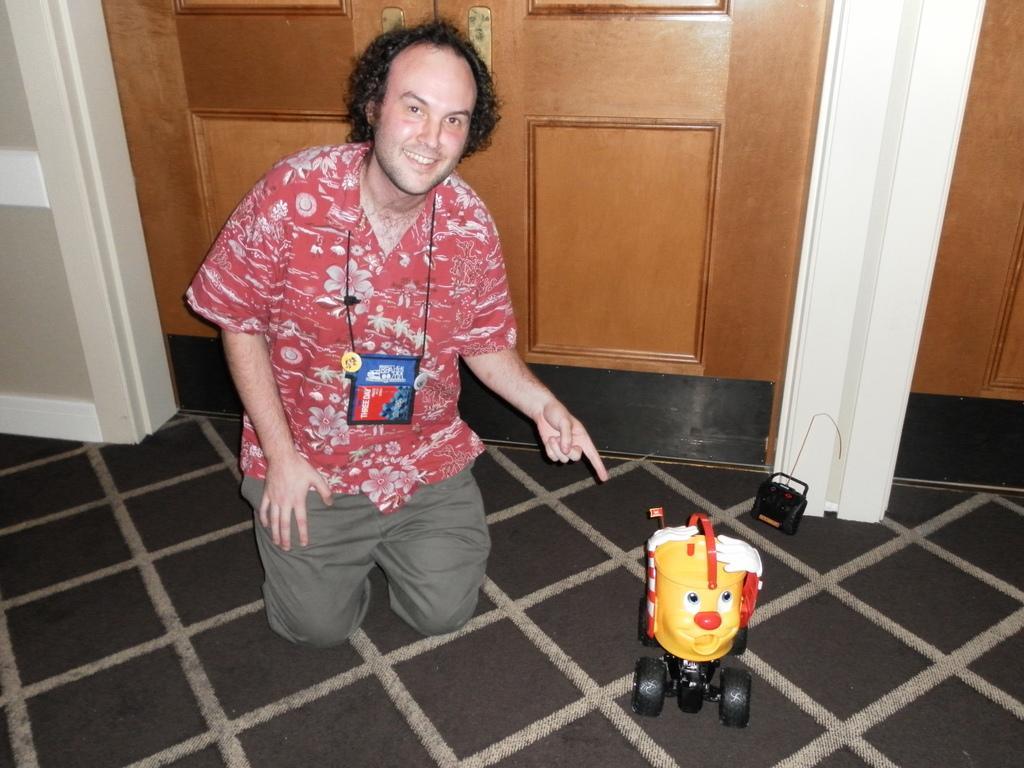In one or two sentences, can you explain what this image depicts? In the foreground of the picture there is a remote control toy and a person, behind him it is a door. On the left there is pillar. 